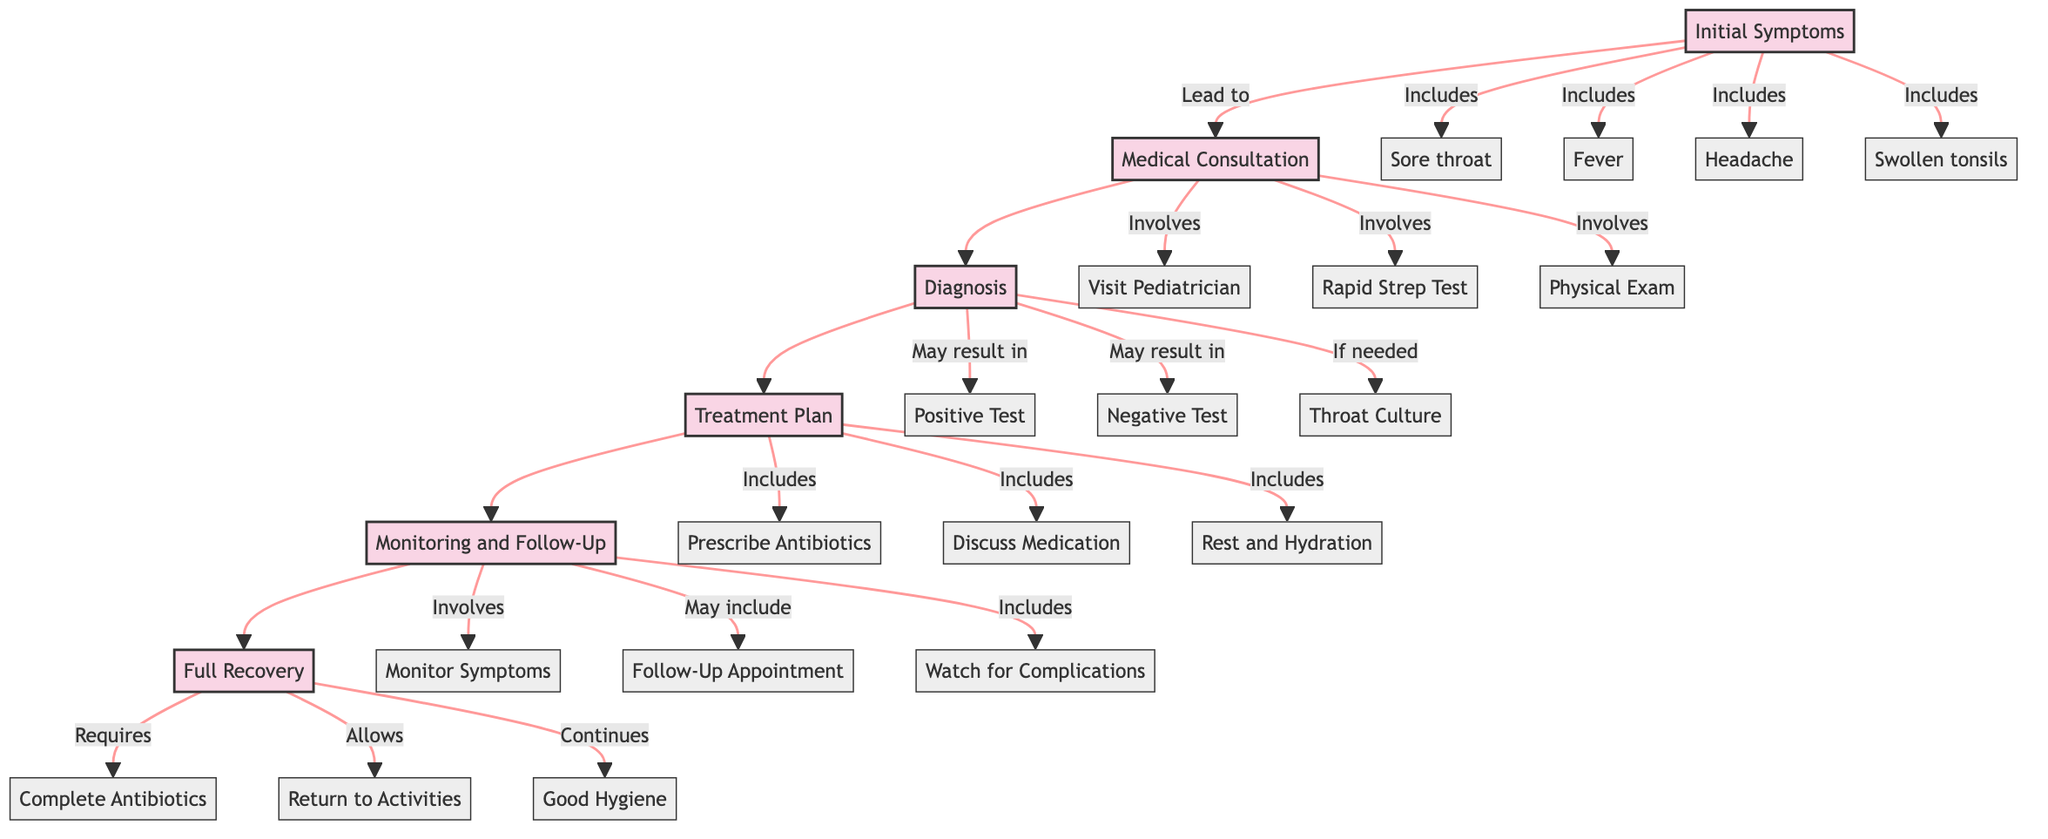What are the first symptoms listed for strep throat? The diagram lists the first symptoms under the "Initial Symptoms" stage. These include a sore throat, fever, headache, and swollen tonsils. The first symptom mentioned is "Sore throat."
Answer: Sore throat How many steps are involved in the "Medical Consultation" stage? In the "Medical Consultation" stage, there are three steps present: visiting a pediatrician, throat swab for a rapid strep test, and a physical examination. Counting these steps gives us three.
Answer: 3 What is the last step in the "Full Recovery" stage? To find the last step in the "Full Recovery" stage, we look at the steps outlined under that stage. The steps include completing the antibiotic course, returning to normal activities, and continuing good hygiene practices. The last step is "Continue Good Hygiene Practices."
Answer: Continue Good Hygiene Practices What happens if the rapid strep test is negative? When the rapid strep test is negative, the diagram indicates that a throat culture may be considered if necessary. This step is outlined in the "Diagnosis" stage and shows the possible follow-up after a negative result.
Answer: Consider Throat Culture if Necessary What should be monitored within 48 hours during the treatment process? The diagram specifies that "Monitor Symptoms Improvement" should happen within 48 hours during the "Monitoring and Follow-Up" stage. This step emphasizes checking how well the symptoms are improving after treatment has started.
Answer: Monitor Symptoms Improvement 